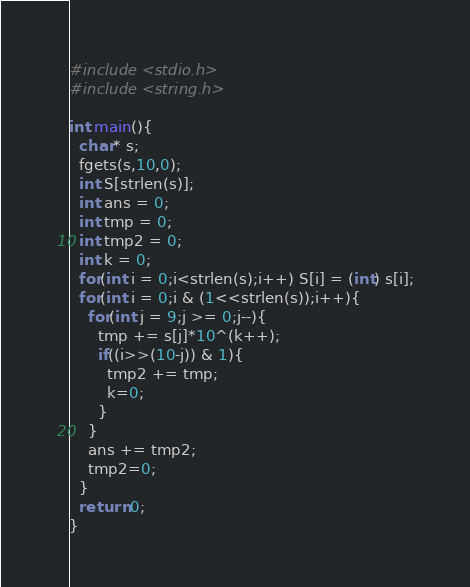Convert code to text. <code><loc_0><loc_0><loc_500><loc_500><_C_>#include <stdio.h>
#include <string.h>

int main(){
  char* s;
  fgets(s,10,0);
  int S[strlen(s)];
  int ans = 0;
  int tmp = 0;
  int tmp2 = 0;
  int k = 0;
  for(int i = 0;i<strlen(s);i++) S[i] = (int) s[i];
  for(int i = 0;i & (1<<strlen(s));i++){
    for(int j = 9;j >= 0;j--){
      tmp += s[j]*10^(k++);
      if((i>>(10-j)) & 1){
        tmp2 += tmp;
        k=0;
      }
    }
    ans += tmp2;
    tmp2=0;
  }
  return 0;
}</code> 